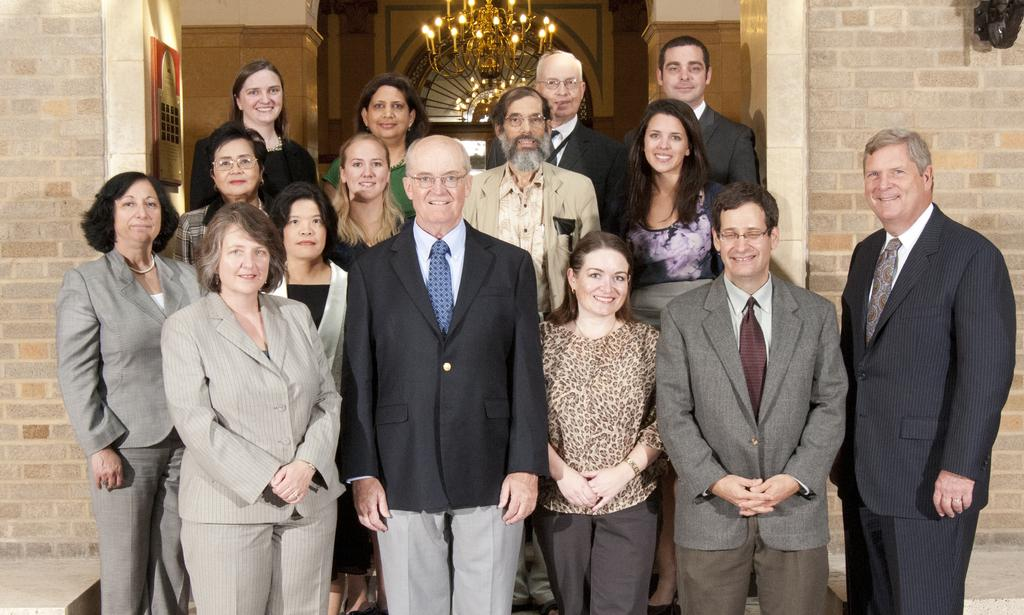What can be seen in the front of the image? There is a group of people in the front of the image. What are the people in the image doing? The people are standing and smiling. What can be seen in the background of the image? There are walls, a board, a chandelier, and glass in the background of the image. Can you describe the board in the background? The board is on a wall in the background of the image. What type of lighting fixture is visible in the background? There is a chandelier in the background of the image. What color is the suit worn by the person in the image? There is no person wearing a suit in the image; the people are wearing casual clothing. 